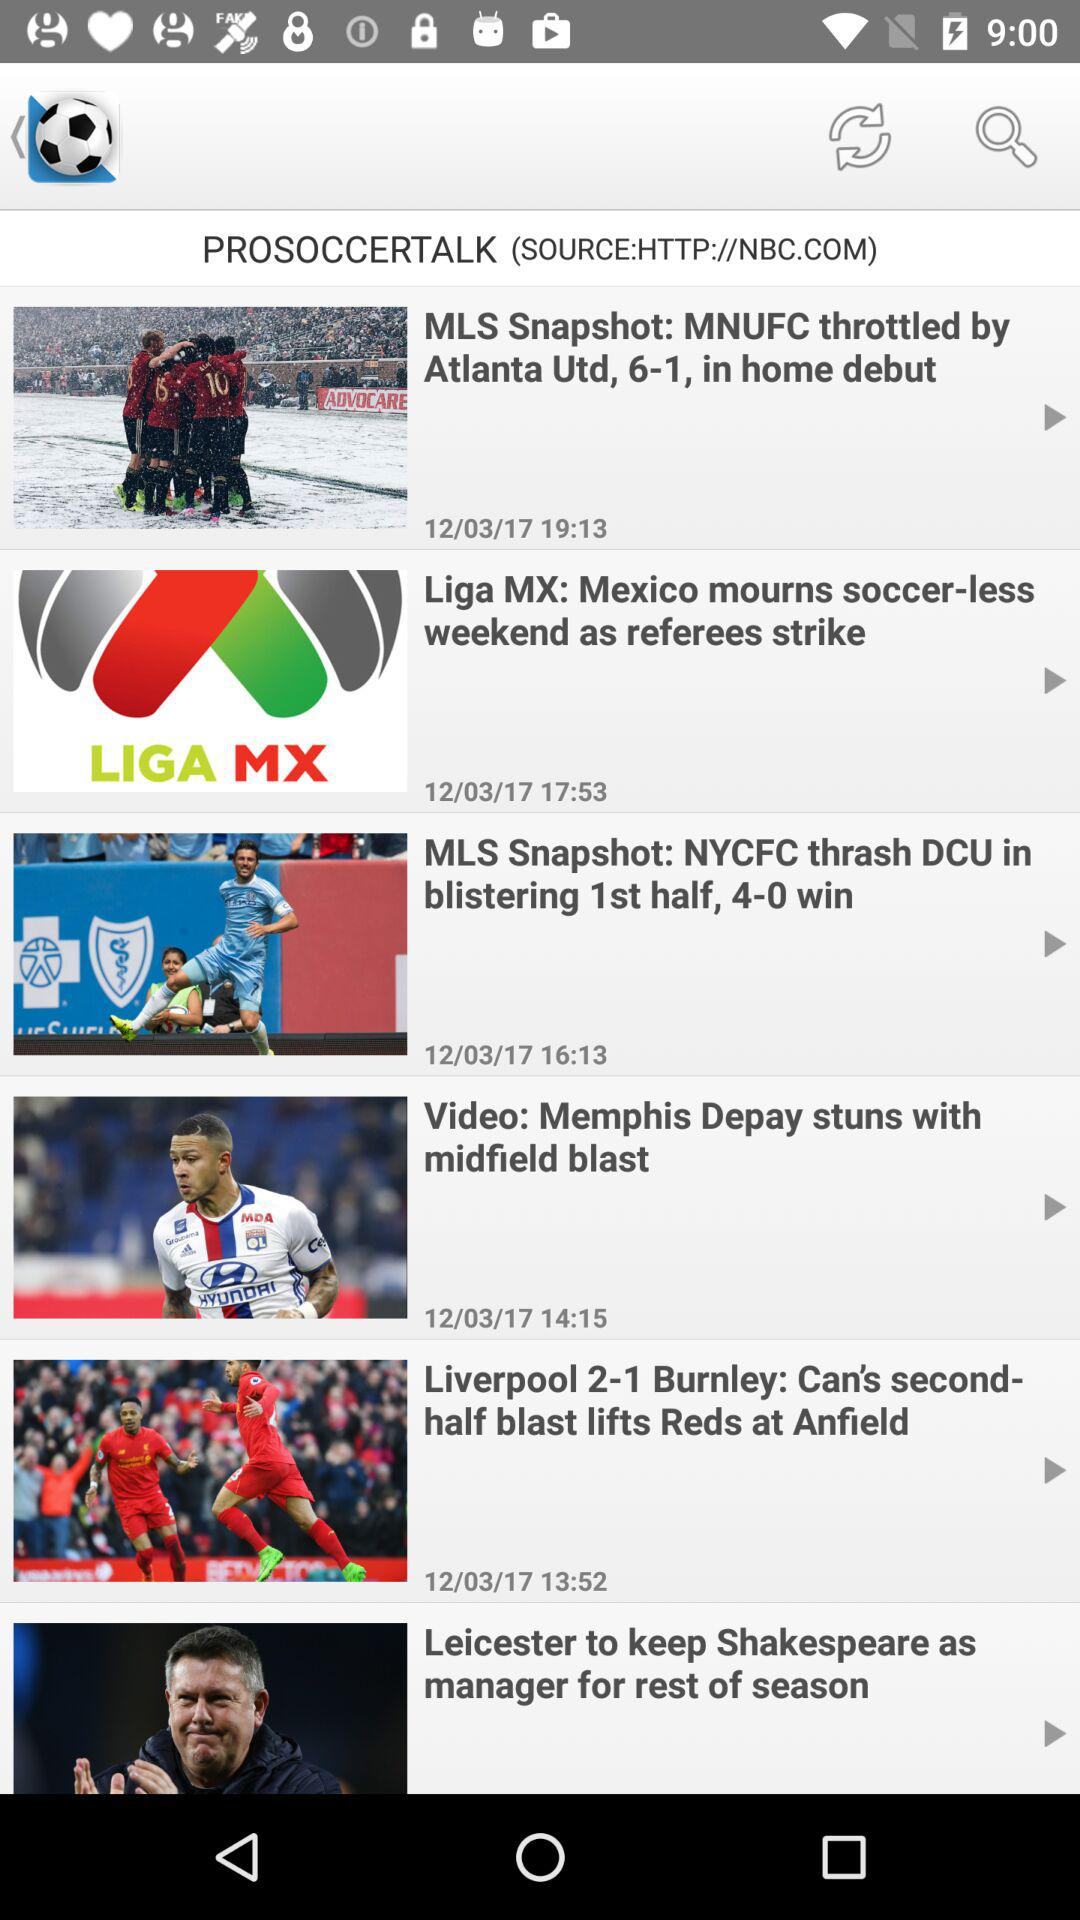Liverpool 2-1 Burnley headlines published at what time? The headlines are published at 13:52. 